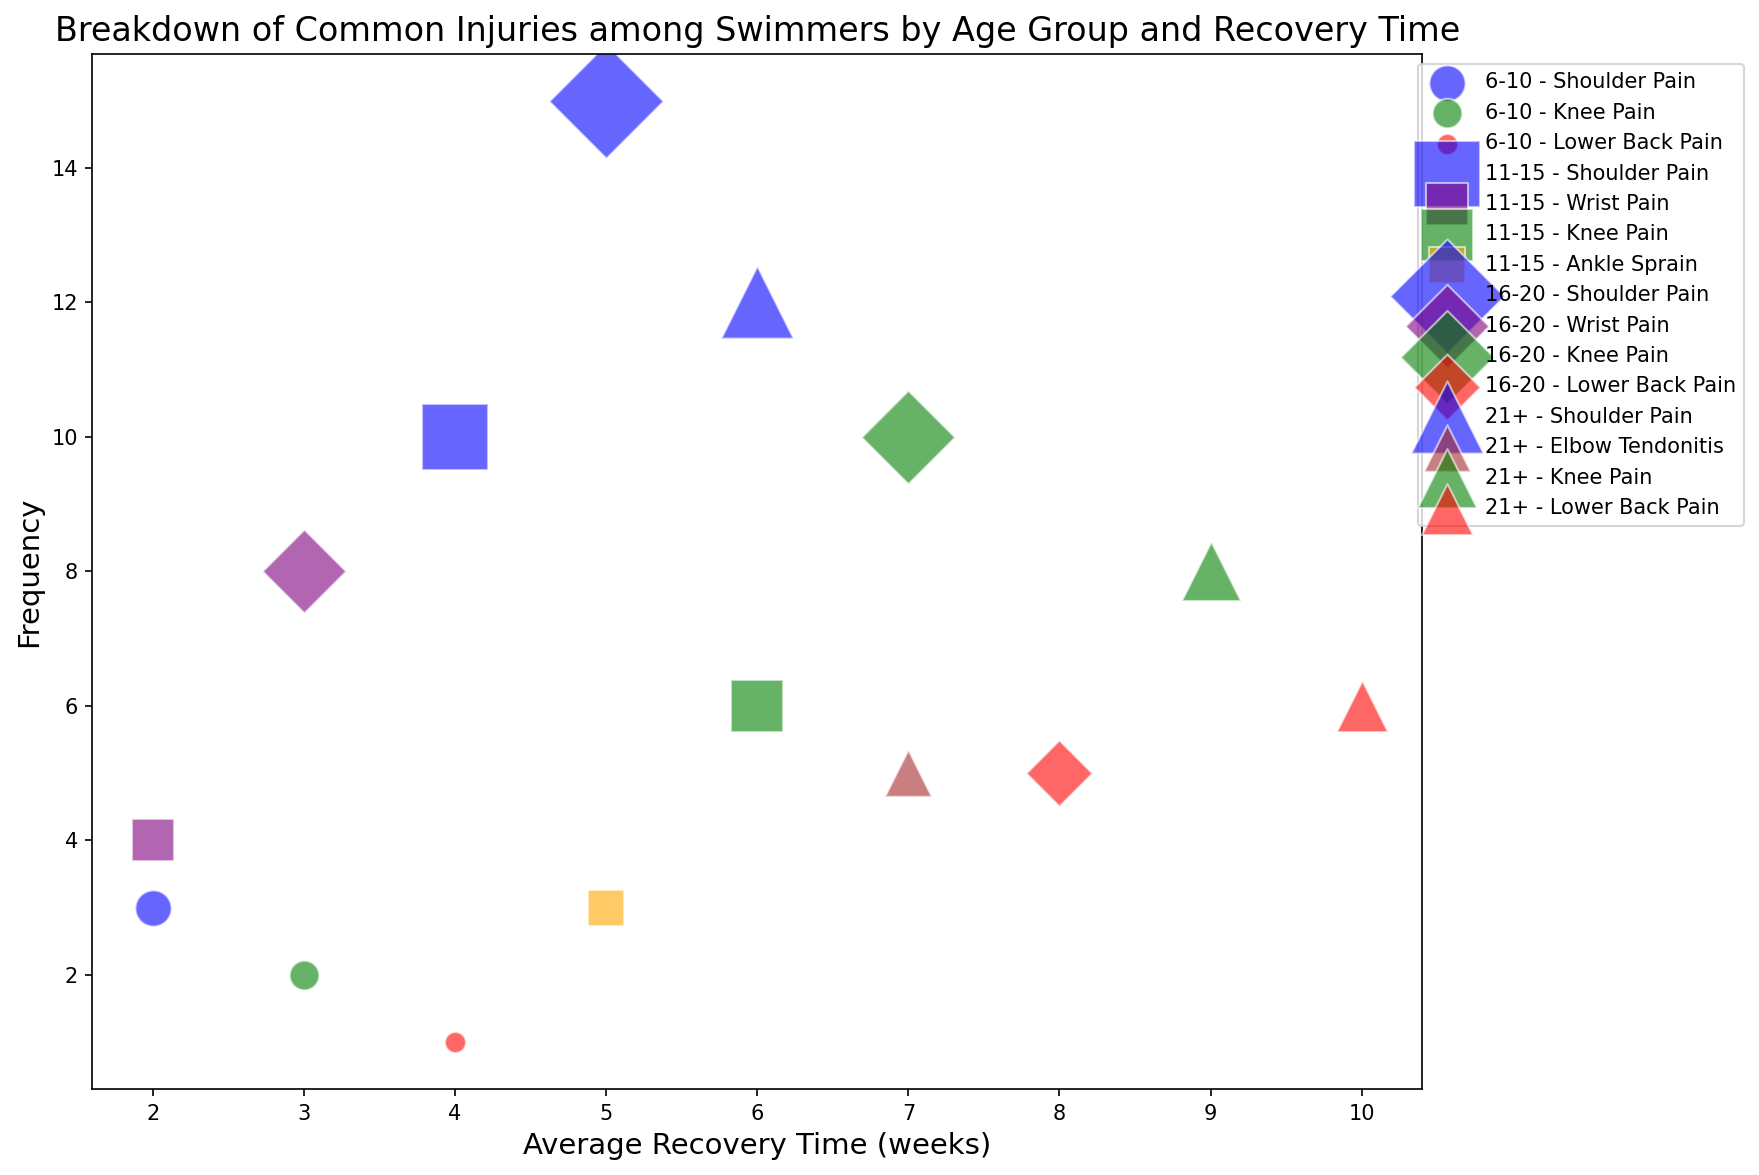What is the most frequent injury among the 16-20 age group? The data points for the 16-20 age group can be identified by the diamond markers. Among these, Shoulder Pain is the most frequent injury with a count of 15.
Answer: Shoulder Pain Which injury among the 21+ age group has the longest average recovery time? For the 21+ age group, indicated by triangle markers, the Lower Back Pain has the longest average recovery time of 10 weeks.
Answer: Lower Back Pain How many different types of injuries are represented in the age group 11-15? The age group 11-15 is represented by square markers. By observing the distinct colors (representing different injuries): Shoulder Pain, Wrist Pain, Knee Pain, and Ankle Sprain, we count 4 different injuries.
Answer: 4 Compare the average recovery time of Shoulder Pain between the 11-15 age group and the 21+ age group. Which is longer, and by how many weeks? Shoulder Pain (blue color) for the 11-15 age group has an average recovery time of 4 weeks. For the 21+ age group, the average recovery time is 6 weeks. The difference is 2 weeks, with the 21+ group being longer.
Answer: 21+ by 2 weeks What is the total frequency of Lower Back Pain across all age groups? Identifying all red-colored points and summing their frequencies: 1 (6-10) + 5 (16-20) + 6 (21+), the total frequency is 12.
Answer: 12 Which age group has the highest frequency of injuries overall? Summing the frequencies for each age group: 
6-10 = 3 (Shoulder Pain) + 2 (Knee Pain) + 1 (Lower Back Pain) = 6
11-15 = 10 (Shoulder Pain) + 4 (Wrist Pain) + 6 (Knee Pain) + 3 (Ankle Sprain) = 23
16-20 = 15 (Shoulder Pain) + 8 (Wrist Pain) + 10 (Knee Pain) + 5 (Lower Back Pain) = 38
21+ = 12 (Shoulder Pain) + 5 (Elbow Tendonitis) + 8 (Knee Pain) + 6 (Lower Back Pain) = 31
The 16-20 age group has the highest frequency.
Answer: 16-20 What is the frequency of Knee Pain for the age group with the shortest average recovery time for this injury? Knee Pain (green color) has average recovery times of: 6-10 = 3 weeks, 11-15 = 6 weeks, 16-20 = 7 weeks, and 21+ = 9 weeks. The shortest average recovery time is 3 weeks for the 6-10 group, with a frequency of 2.
Answer: 2 What is the average recovery time for all injuries in the 11-15 age group? Identify the recovery times for all injuries (square markers) in the 11-15 group: 
4 (Shoulder Pain) + 2 (Wrist Pain) + 6 (Knee Pain) + 5 (Ankle Sprain)
The total is 17 weeks. There are 4 injuries, so the average recovery time is 17/4 = 4.25 weeks.
Answer: 4.25 weeks 